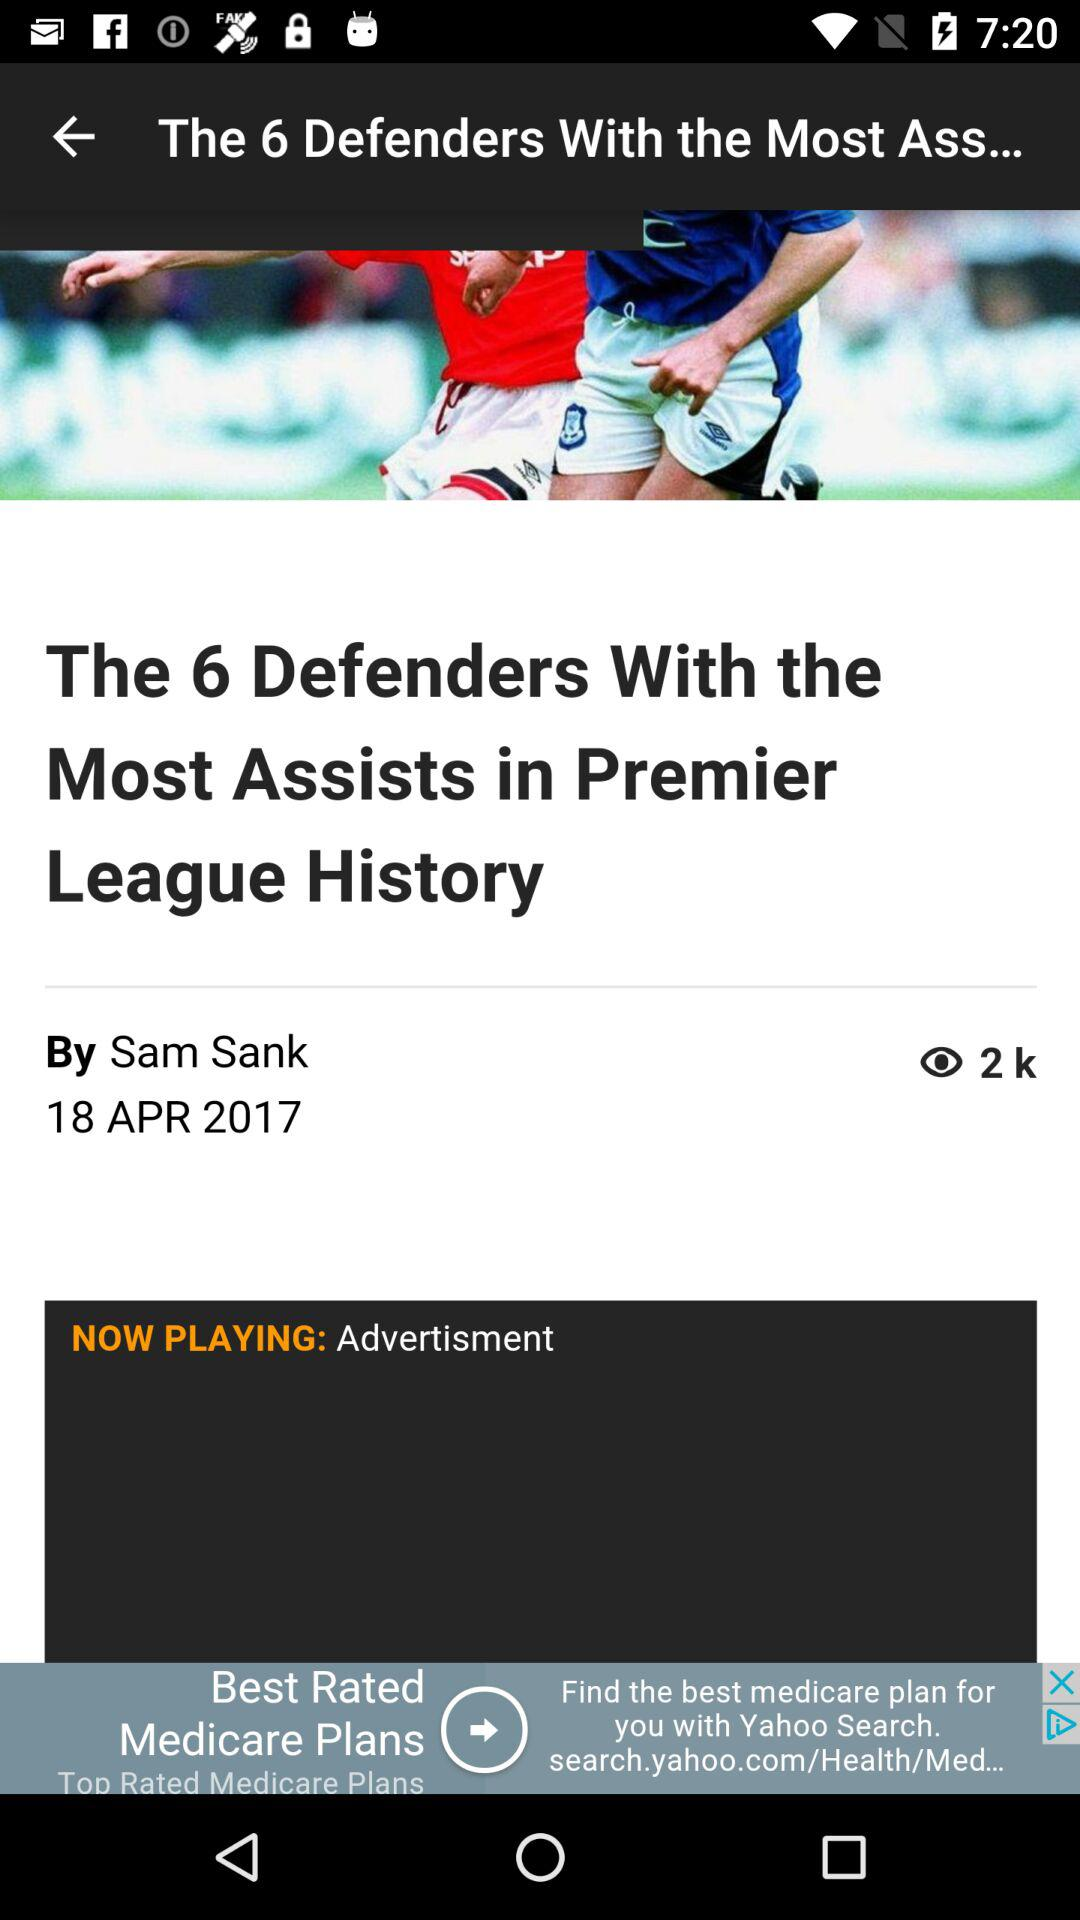Who is the author of the article? The author of the article is Sam Sank. 